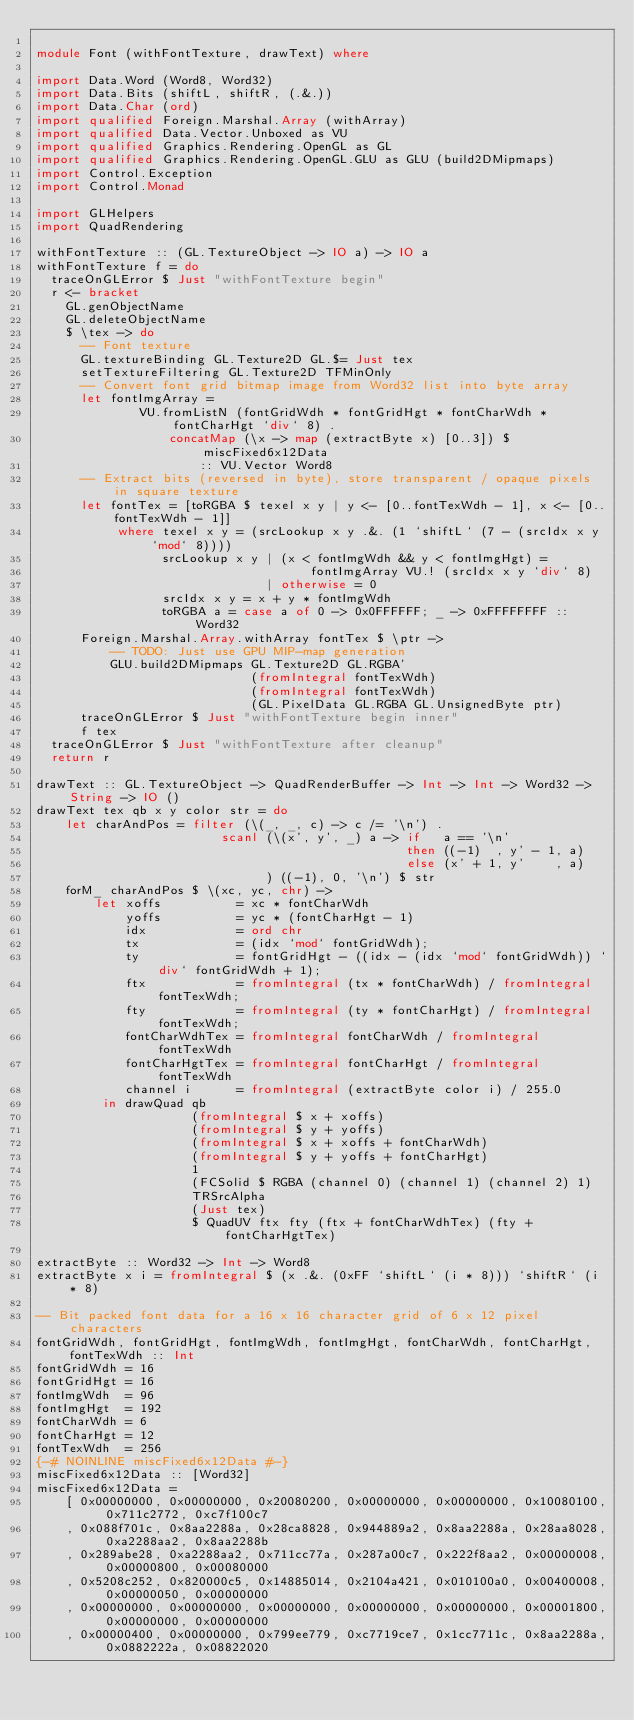<code> <loc_0><loc_0><loc_500><loc_500><_Haskell_>
module Font (withFontTexture, drawText) where

import Data.Word (Word8, Word32)
import Data.Bits (shiftL, shiftR, (.&.))
import Data.Char (ord)
import qualified Foreign.Marshal.Array (withArray)
import qualified Data.Vector.Unboxed as VU
import qualified Graphics.Rendering.OpenGL as GL
import qualified Graphics.Rendering.OpenGL.GLU as GLU (build2DMipmaps)
import Control.Exception
import Control.Monad

import GLHelpers
import QuadRendering

withFontTexture :: (GL.TextureObject -> IO a) -> IO a
withFontTexture f = do
  traceOnGLError $ Just "withFontTexture begin"
  r <- bracket
    GL.genObjectName
    GL.deleteObjectName
    $ \tex -> do
      -- Font texture
      GL.textureBinding GL.Texture2D GL.$= Just tex
      setTextureFiltering GL.Texture2D TFMinOnly
      -- Convert font grid bitmap image from Word32 list into byte array
      let fontImgArray =
              VU.fromListN (fontGridWdh * fontGridHgt * fontCharWdh * fontCharHgt `div` 8) .
                  concatMap (\x -> map (extractByte x) [0..3]) $ miscFixed6x12Data
                      :: VU.Vector Word8
      -- Extract bits (reversed in byte), store transparent / opaque pixels in square texture
      let fontTex = [toRGBA $ texel x y | y <- [0..fontTexWdh - 1], x <- [0..fontTexWdh - 1]]
           where texel x y = (srcLookup x y .&. (1 `shiftL` (7 - (srcIdx x y `mod` 8))))
                 srcLookup x y | (x < fontImgWdh && y < fontImgHgt) =
                                     fontImgArray VU.! (srcIdx x y `div` 8)
                               | otherwise = 0
                 srcIdx x y = x + y * fontImgWdh
                 toRGBA a = case a of 0 -> 0x0FFFFFF; _ -> 0xFFFFFFFF :: Word32
      Foreign.Marshal.Array.withArray fontTex $ \ptr ->
          -- TODO: Just use GPU MIP-map generation
          GLU.build2DMipmaps GL.Texture2D GL.RGBA'
                             (fromIntegral fontTexWdh)
                             (fromIntegral fontTexWdh)
                             (GL.PixelData GL.RGBA GL.UnsignedByte ptr)
      traceOnGLError $ Just "withFontTexture begin inner"
      f tex
  traceOnGLError $ Just "withFontTexture after cleanup"
  return r

drawText :: GL.TextureObject -> QuadRenderBuffer -> Int -> Int -> Word32 -> String -> IO ()
drawText tex qb x y color str = do
    let charAndPos = filter (\(_, _, c) -> c /= '\n') .
                         scanl (\(x', y', _) a -> if   a == '\n'
                                                  then ((-1)  , y' - 1, a)
                                                  else (x' + 1, y'    , a)
                               ) ((-1), 0, '\n') $ str
    forM_ charAndPos $ \(xc, yc, chr) ->
        let xoffs          = xc * fontCharWdh
            yoffs          = yc * (fontCharHgt - 1)
            idx            = ord chr
            tx             = (idx `mod` fontGridWdh);
            ty             = fontGridHgt - ((idx - (idx `mod` fontGridWdh)) `div` fontGridWdh + 1);
            ftx            = fromIntegral (tx * fontCharWdh) / fromIntegral fontTexWdh;
            fty            = fromIntegral (ty * fontCharHgt) / fromIntegral fontTexWdh;
            fontCharWdhTex = fromIntegral fontCharWdh / fromIntegral fontTexWdh
            fontCharHgtTex = fromIntegral fontCharHgt / fromIntegral fontTexWdh
            channel i      = fromIntegral (extractByte color i) / 255.0
         in drawQuad qb
                     (fromIntegral $ x + xoffs)
                     (fromIntegral $ y + yoffs)
                     (fromIntegral $ x + xoffs + fontCharWdh)
                     (fromIntegral $ y + yoffs + fontCharHgt)
                     1
                     (FCSolid $ RGBA (channel 0) (channel 1) (channel 2) 1)
                     TRSrcAlpha
                     (Just tex)
                     $ QuadUV ftx fty (ftx + fontCharWdhTex) (fty + fontCharHgtTex)

extractByte :: Word32 -> Int -> Word8
extractByte x i = fromIntegral $ (x .&. (0xFF `shiftL` (i * 8))) `shiftR` (i * 8)

-- Bit packed font data for a 16 x 16 character grid of 6 x 12 pixel characters
fontGridWdh, fontGridHgt, fontImgWdh, fontImgHgt, fontCharWdh, fontCharHgt, fontTexWdh :: Int
fontGridWdh = 16
fontGridHgt = 16
fontImgWdh  = 96
fontImgHgt  = 192
fontCharWdh = 6
fontCharHgt = 12
fontTexWdh  = 256
{-# NOINLINE miscFixed6x12Data #-}
miscFixed6x12Data :: [Word32]
miscFixed6x12Data =
    [ 0x00000000, 0x00000000, 0x20080200, 0x00000000, 0x00000000, 0x10080100, 0x711c2772, 0xc7f100c7
    , 0x088f701c, 0x8aa2288a, 0x28ca8828, 0x944889a2, 0x8aa2288a, 0x28aa8028, 0xa2288aa2, 0x8aa2288b
    , 0x289abe28, 0xa2288aa2, 0x711cc77a, 0x287a00c7, 0x222f8aa2, 0x00000008, 0x00000800, 0x00080000
    , 0x5208c252, 0x820000c5, 0x14885014, 0x2104a421, 0x010100a0, 0x00400008, 0x00000050, 0x00000000
    , 0x00000000, 0x00000000, 0x00000000, 0x00000000, 0x00000000, 0x00001800, 0x00000000, 0x00000000
    , 0x00000400, 0x00000000, 0x799ee779, 0xc7719ce7, 0x1cc7711c, 0x8aa2288a, 0x0882222a, 0x08822020</code> 